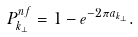<formula> <loc_0><loc_0><loc_500><loc_500>P _ { { k } _ { \perp } } ^ { n f } = 1 - e ^ { - 2 \pi a _ { { k } _ { \perp } } } .</formula> 